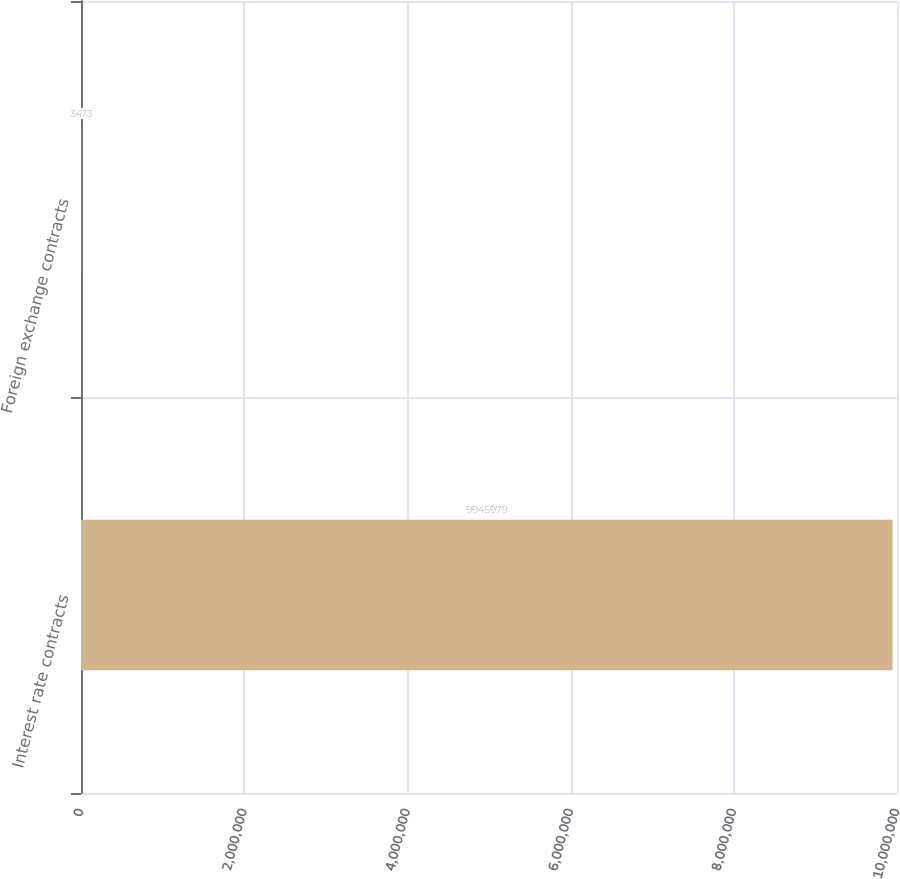Convert chart. <chart><loc_0><loc_0><loc_500><loc_500><bar_chart><fcel>Interest rate contracts<fcel>Foreign exchange contracts<nl><fcel>9.94598e+06<fcel>3473<nl></chart> 